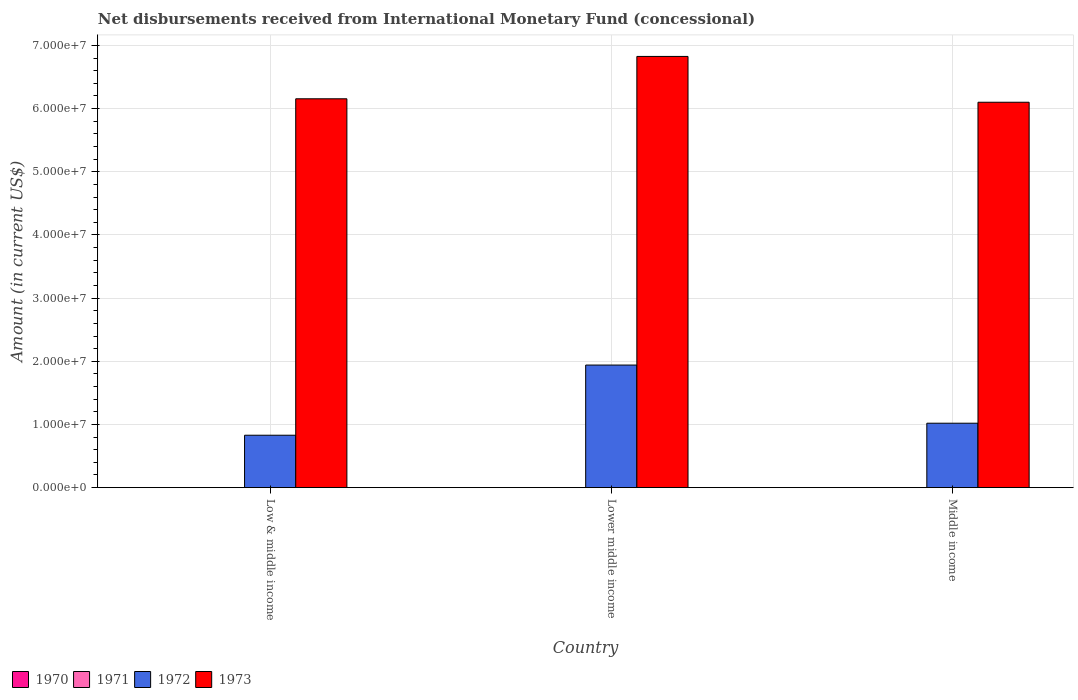How many groups of bars are there?
Your answer should be very brief. 3. In how many cases, is the number of bars for a given country not equal to the number of legend labels?
Offer a terse response. 3. What is the amount of disbursements received from International Monetary Fund in 1972 in Middle income?
Ensure brevity in your answer.  1.02e+07. Across all countries, what is the maximum amount of disbursements received from International Monetary Fund in 1973?
Your answer should be very brief. 6.83e+07. Across all countries, what is the minimum amount of disbursements received from International Monetary Fund in 1972?
Offer a very short reply. 8.30e+06. What is the total amount of disbursements received from International Monetary Fund in 1971 in the graph?
Give a very brief answer. 0. What is the difference between the amount of disbursements received from International Monetary Fund in 1972 in Lower middle income and that in Middle income?
Offer a very short reply. 9.21e+06. What is the difference between the amount of disbursements received from International Monetary Fund in 1973 in Lower middle income and the amount of disbursements received from International Monetary Fund in 1970 in Middle income?
Offer a terse response. 6.83e+07. What is the difference between the amount of disbursements received from International Monetary Fund of/in 1973 and amount of disbursements received from International Monetary Fund of/in 1972 in Low & middle income?
Offer a terse response. 5.33e+07. In how many countries, is the amount of disbursements received from International Monetary Fund in 1972 greater than 22000000 US$?
Provide a succinct answer. 0. What is the ratio of the amount of disbursements received from International Monetary Fund in 1973 in Low & middle income to that in Middle income?
Your answer should be compact. 1.01. Is the amount of disbursements received from International Monetary Fund in 1972 in Lower middle income less than that in Middle income?
Ensure brevity in your answer.  No. Is the difference between the amount of disbursements received from International Monetary Fund in 1973 in Lower middle income and Middle income greater than the difference between the amount of disbursements received from International Monetary Fund in 1972 in Lower middle income and Middle income?
Ensure brevity in your answer.  No. What is the difference between the highest and the second highest amount of disbursements received from International Monetary Fund in 1972?
Provide a succinct answer. 9.21e+06. What is the difference between the highest and the lowest amount of disbursements received from International Monetary Fund in 1973?
Make the answer very short. 7.25e+06. In how many countries, is the amount of disbursements received from International Monetary Fund in 1972 greater than the average amount of disbursements received from International Monetary Fund in 1972 taken over all countries?
Keep it short and to the point. 1. How many countries are there in the graph?
Keep it short and to the point. 3. Are the values on the major ticks of Y-axis written in scientific E-notation?
Keep it short and to the point. Yes. Does the graph contain any zero values?
Your answer should be very brief. Yes. Where does the legend appear in the graph?
Offer a terse response. Bottom left. How many legend labels are there?
Your answer should be compact. 4. How are the legend labels stacked?
Your answer should be very brief. Horizontal. What is the title of the graph?
Make the answer very short. Net disbursements received from International Monetary Fund (concessional). Does "1996" appear as one of the legend labels in the graph?
Provide a succinct answer. No. What is the label or title of the X-axis?
Provide a short and direct response. Country. What is the label or title of the Y-axis?
Offer a terse response. Amount (in current US$). What is the Amount (in current US$) in 1970 in Low & middle income?
Your answer should be compact. 0. What is the Amount (in current US$) in 1972 in Low & middle income?
Ensure brevity in your answer.  8.30e+06. What is the Amount (in current US$) of 1973 in Low & middle income?
Your answer should be very brief. 6.16e+07. What is the Amount (in current US$) in 1972 in Lower middle income?
Make the answer very short. 1.94e+07. What is the Amount (in current US$) of 1973 in Lower middle income?
Make the answer very short. 6.83e+07. What is the Amount (in current US$) of 1971 in Middle income?
Make the answer very short. 0. What is the Amount (in current US$) in 1972 in Middle income?
Make the answer very short. 1.02e+07. What is the Amount (in current US$) in 1973 in Middle income?
Provide a succinct answer. 6.10e+07. Across all countries, what is the maximum Amount (in current US$) in 1972?
Offer a terse response. 1.94e+07. Across all countries, what is the maximum Amount (in current US$) of 1973?
Provide a short and direct response. 6.83e+07. Across all countries, what is the minimum Amount (in current US$) of 1972?
Provide a short and direct response. 8.30e+06. Across all countries, what is the minimum Amount (in current US$) in 1973?
Ensure brevity in your answer.  6.10e+07. What is the total Amount (in current US$) of 1972 in the graph?
Keep it short and to the point. 3.79e+07. What is the total Amount (in current US$) in 1973 in the graph?
Provide a succinct answer. 1.91e+08. What is the difference between the Amount (in current US$) of 1972 in Low & middle income and that in Lower middle income?
Provide a succinct answer. -1.11e+07. What is the difference between the Amount (in current US$) of 1973 in Low & middle income and that in Lower middle income?
Provide a succinct answer. -6.70e+06. What is the difference between the Amount (in current US$) in 1972 in Low & middle income and that in Middle income?
Your response must be concise. -1.90e+06. What is the difference between the Amount (in current US$) of 1973 in Low & middle income and that in Middle income?
Offer a very short reply. 5.46e+05. What is the difference between the Amount (in current US$) of 1972 in Lower middle income and that in Middle income?
Your answer should be very brief. 9.21e+06. What is the difference between the Amount (in current US$) in 1973 in Lower middle income and that in Middle income?
Offer a very short reply. 7.25e+06. What is the difference between the Amount (in current US$) of 1972 in Low & middle income and the Amount (in current US$) of 1973 in Lower middle income?
Provide a short and direct response. -6.00e+07. What is the difference between the Amount (in current US$) of 1972 in Low & middle income and the Amount (in current US$) of 1973 in Middle income?
Your answer should be compact. -5.27e+07. What is the difference between the Amount (in current US$) of 1972 in Lower middle income and the Amount (in current US$) of 1973 in Middle income?
Give a very brief answer. -4.16e+07. What is the average Amount (in current US$) in 1970 per country?
Offer a very short reply. 0. What is the average Amount (in current US$) in 1972 per country?
Provide a succinct answer. 1.26e+07. What is the average Amount (in current US$) in 1973 per country?
Provide a succinct answer. 6.36e+07. What is the difference between the Amount (in current US$) in 1972 and Amount (in current US$) in 1973 in Low & middle income?
Keep it short and to the point. -5.33e+07. What is the difference between the Amount (in current US$) in 1972 and Amount (in current US$) in 1973 in Lower middle income?
Keep it short and to the point. -4.89e+07. What is the difference between the Amount (in current US$) in 1972 and Amount (in current US$) in 1973 in Middle income?
Keep it short and to the point. -5.08e+07. What is the ratio of the Amount (in current US$) of 1972 in Low & middle income to that in Lower middle income?
Ensure brevity in your answer.  0.43. What is the ratio of the Amount (in current US$) of 1973 in Low & middle income to that in Lower middle income?
Offer a terse response. 0.9. What is the ratio of the Amount (in current US$) in 1972 in Low & middle income to that in Middle income?
Your response must be concise. 0.81. What is the ratio of the Amount (in current US$) in 1972 in Lower middle income to that in Middle income?
Ensure brevity in your answer.  1.9. What is the ratio of the Amount (in current US$) in 1973 in Lower middle income to that in Middle income?
Keep it short and to the point. 1.12. What is the difference between the highest and the second highest Amount (in current US$) of 1972?
Offer a very short reply. 9.21e+06. What is the difference between the highest and the second highest Amount (in current US$) of 1973?
Provide a succinct answer. 6.70e+06. What is the difference between the highest and the lowest Amount (in current US$) of 1972?
Offer a terse response. 1.11e+07. What is the difference between the highest and the lowest Amount (in current US$) in 1973?
Make the answer very short. 7.25e+06. 